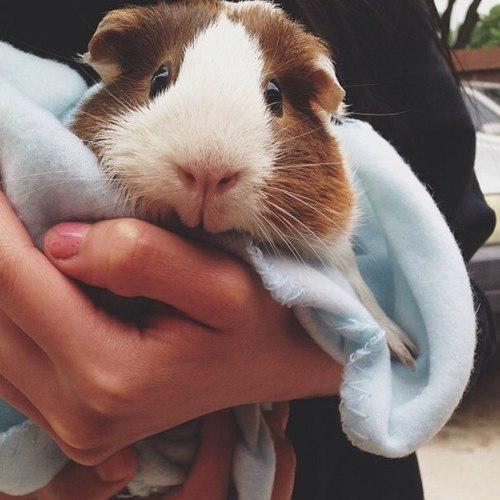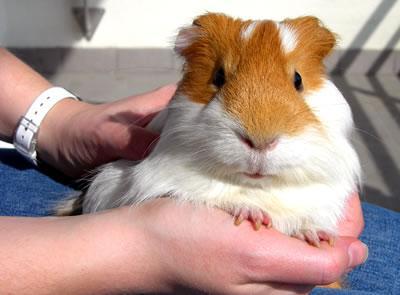The first image is the image on the left, the second image is the image on the right. For the images shown, is this caption "There is a guinea pig in the right image looking towards the right." true? Answer yes or no. No. The first image is the image on the left, the second image is the image on the right. Examine the images to the left and right. Is the description "Each image shows a guinea pigs held in an upturned palm of at least one hand." accurate? Answer yes or no. Yes. 